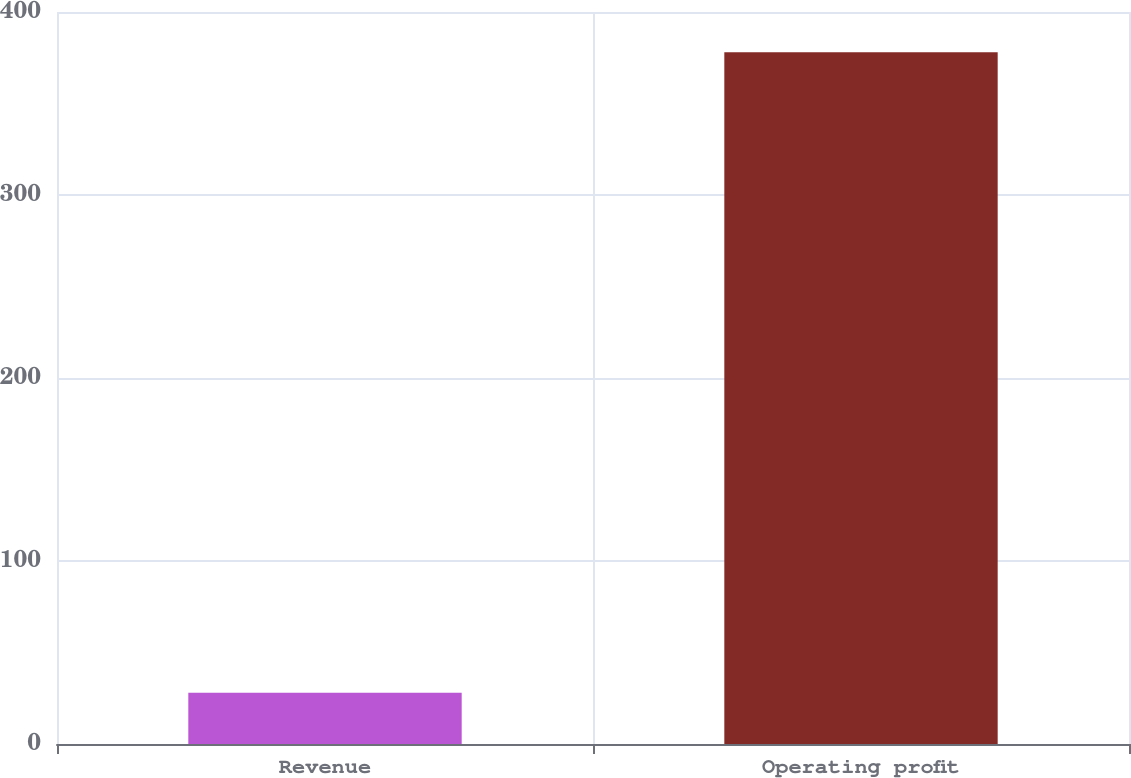Convert chart. <chart><loc_0><loc_0><loc_500><loc_500><bar_chart><fcel>Revenue<fcel>Operating profit<nl><fcel>28<fcel>378<nl></chart> 